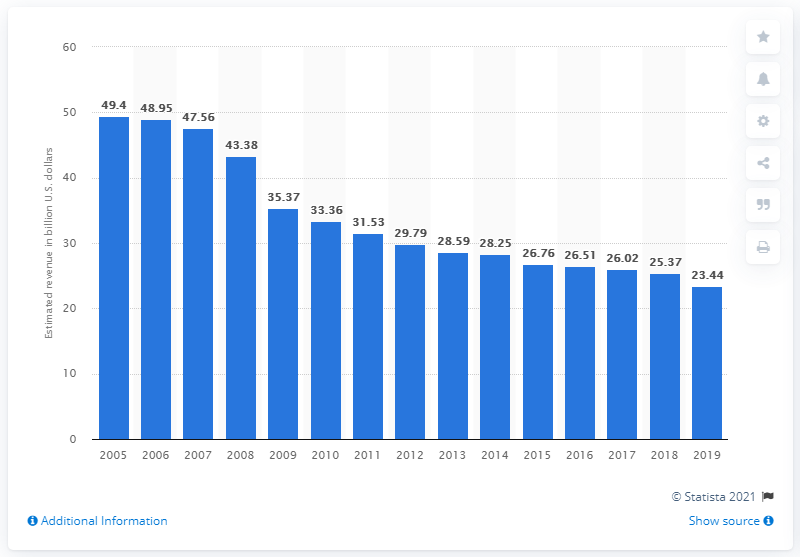Outline some significant characteristics in this image. In the time frame from 2005 to 2019, the lowest annual aggregate revenue of U.S. newspaper publishers was in 2019. The revenue generated by U.S. newspaper publishers in 2019 was 23.44. 